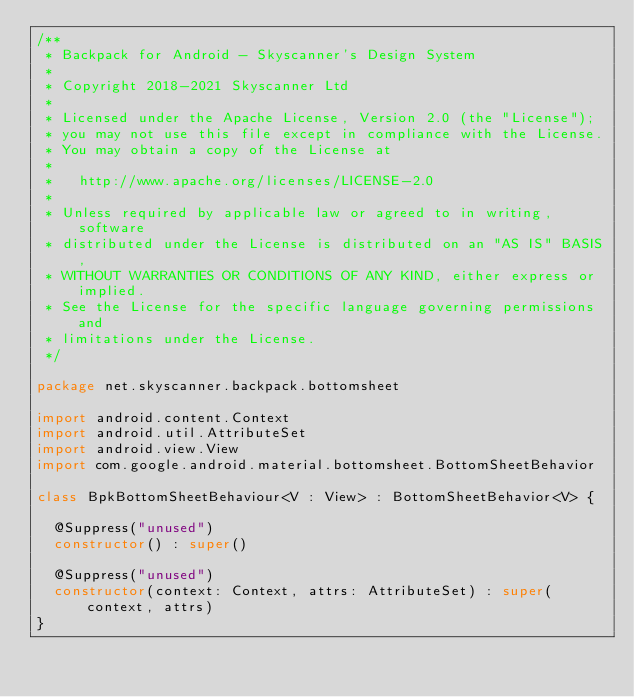Convert code to text. <code><loc_0><loc_0><loc_500><loc_500><_Kotlin_>/**
 * Backpack for Android - Skyscanner's Design System
 *
 * Copyright 2018-2021 Skyscanner Ltd
 *
 * Licensed under the Apache License, Version 2.0 (the "License");
 * you may not use this file except in compliance with the License.
 * You may obtain a copy of the License at
 *
 *   http://www.apache.org/licenses/LICENSE-2.0
 *
 * Unless required by applicable law or agreed to in writing, software
 * distributed under the License is distributed on an "AS IS" BASIS,
 * WITHOUT WARRANTIES OR CONDITIONS OF ANY KIND, either express or implied.
 * See the License for the specific language governing permissions and
 * limitations under the License.
 */

package net.skyscanner.backpack.bottomsheet

import android.content.Context
import android.util.AttributeSet
import android.view.View
import com.google.android.material.bottomsheet.BottomSheetBehavior

class BpkBottomSheetBehaviour<V : View> : BottomSheetBehavior<V> {

  @Suppress("unused")
  constructor() : super()

  @Suppress("unused")
  constructor(context: Context, attrs: AttributeSet) : super(context, attrs)
}
</code> 